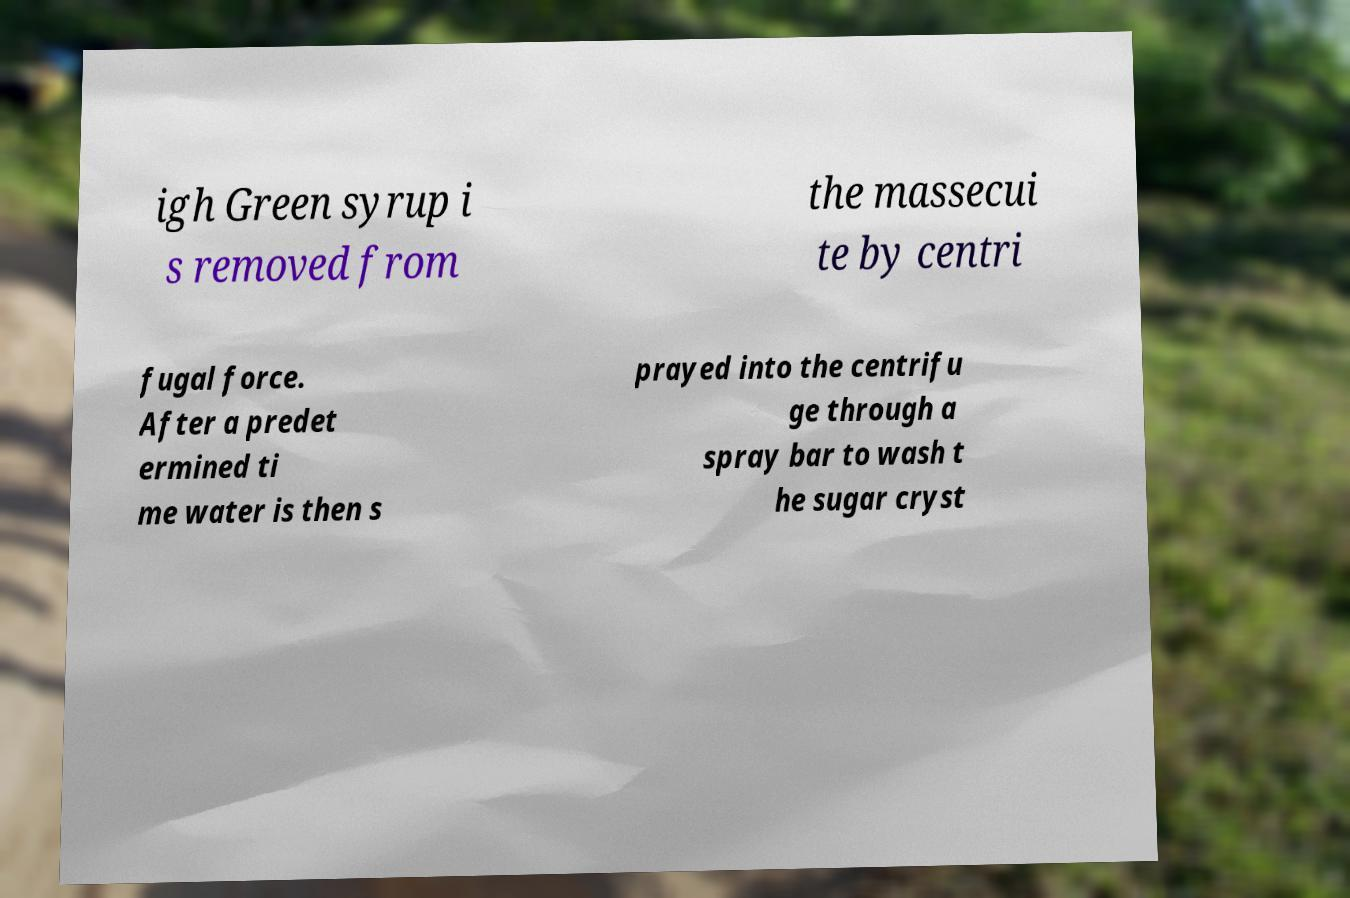Could you extract and type out the text from this image? igh Green syrup i s removed from the massecui te by centri fugal force. After a predet ermined ti me water is then s prayed into the centrifu ge through a spray bar to wash t he sugar cryst 